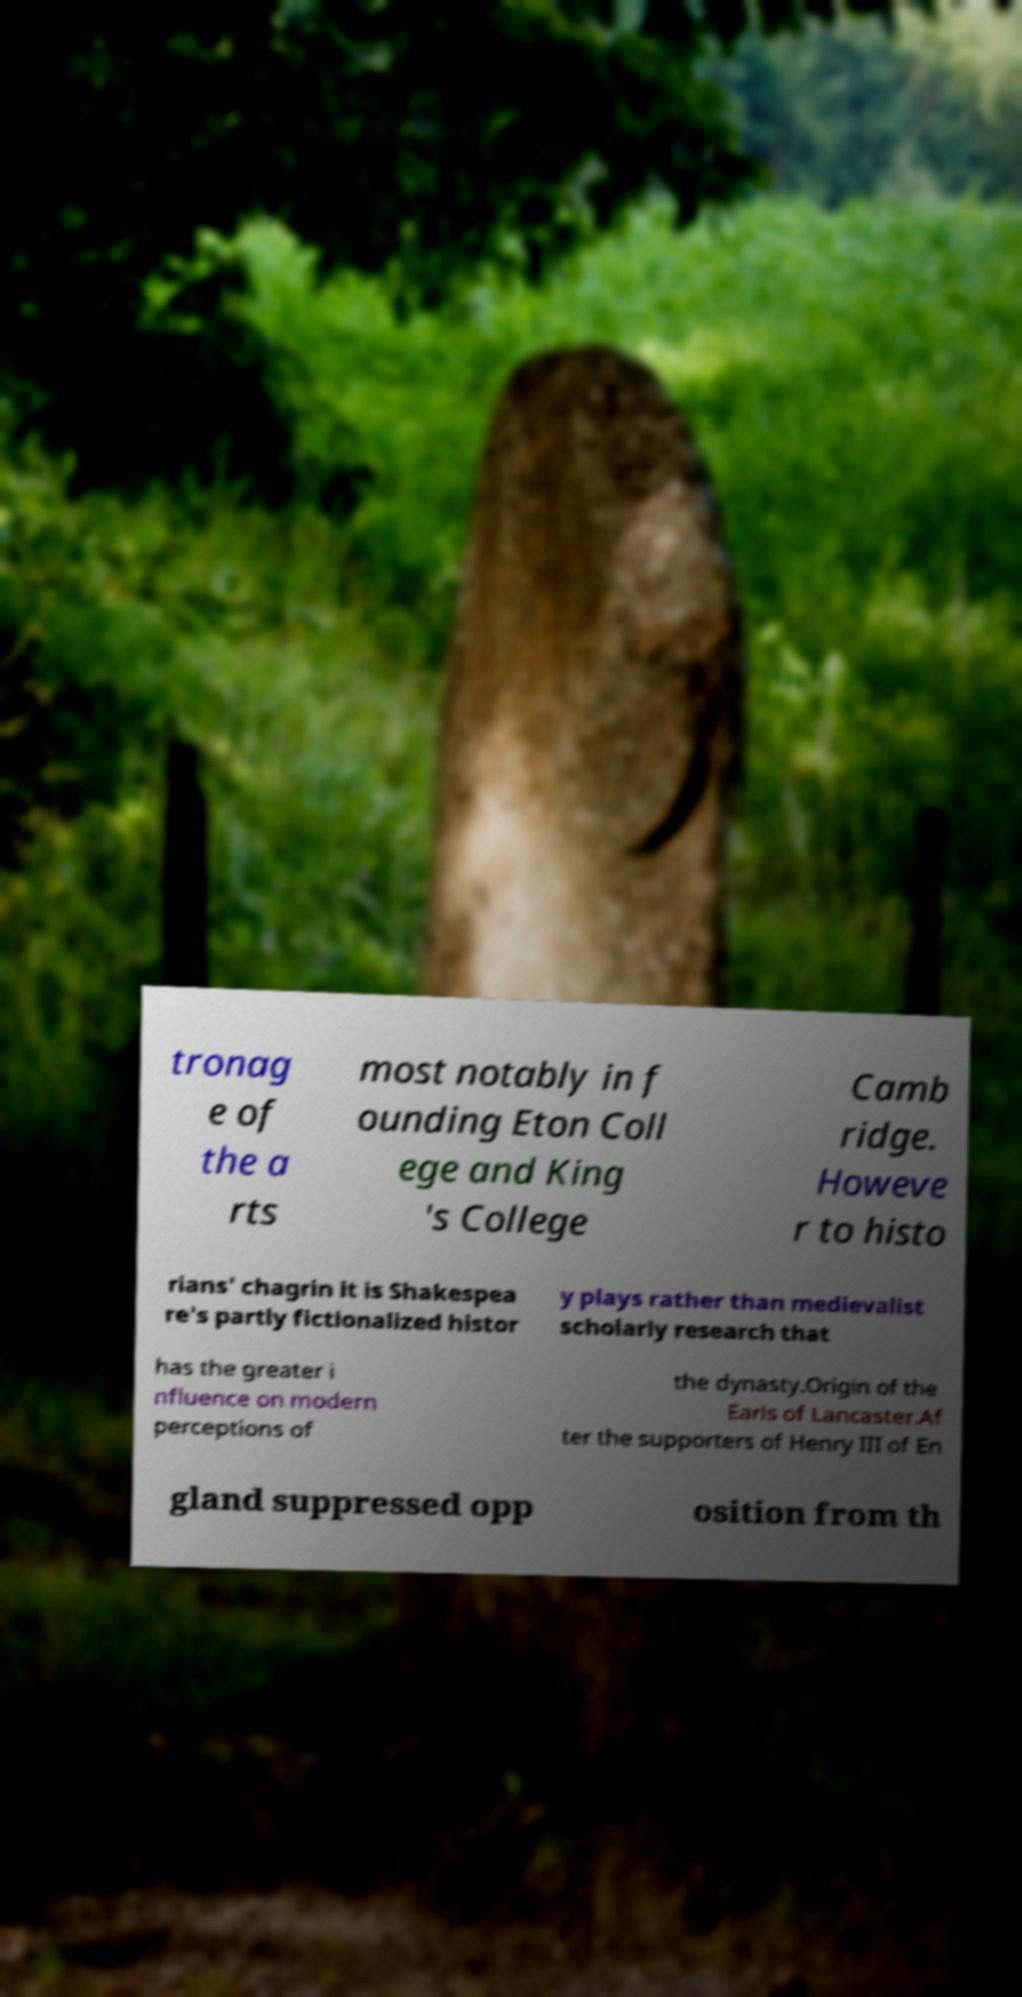Could you extract and type out the text from this image? tronag e of the a rts most notably in f ounding Eton Coll ege and King 's College Camb ridge. Howeve r to histo rians' chagrin it is Shakespea re's partly fictionalized histor y plays rather than medievalist scholarly research that has the greater i nfluence on modern perceptions of the dynasty.Origin of the Earls of Lancaster.Af ter the supporters of Henry III of En gland suppressed opp osition from th 